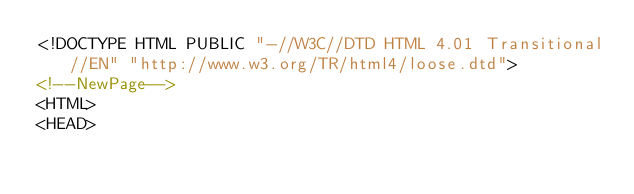<code> <loc_0><loc_0><loc_500><loc_500><_HTML_><!DOCTYPE HTML PUBLIC "-//W3C//DTD HTML 4.01 Transitional//EN" "http://www.w3.org/TR/html4/loose.dtd">
<!--NewPage-->
<HTML>
<HEAD></code> 